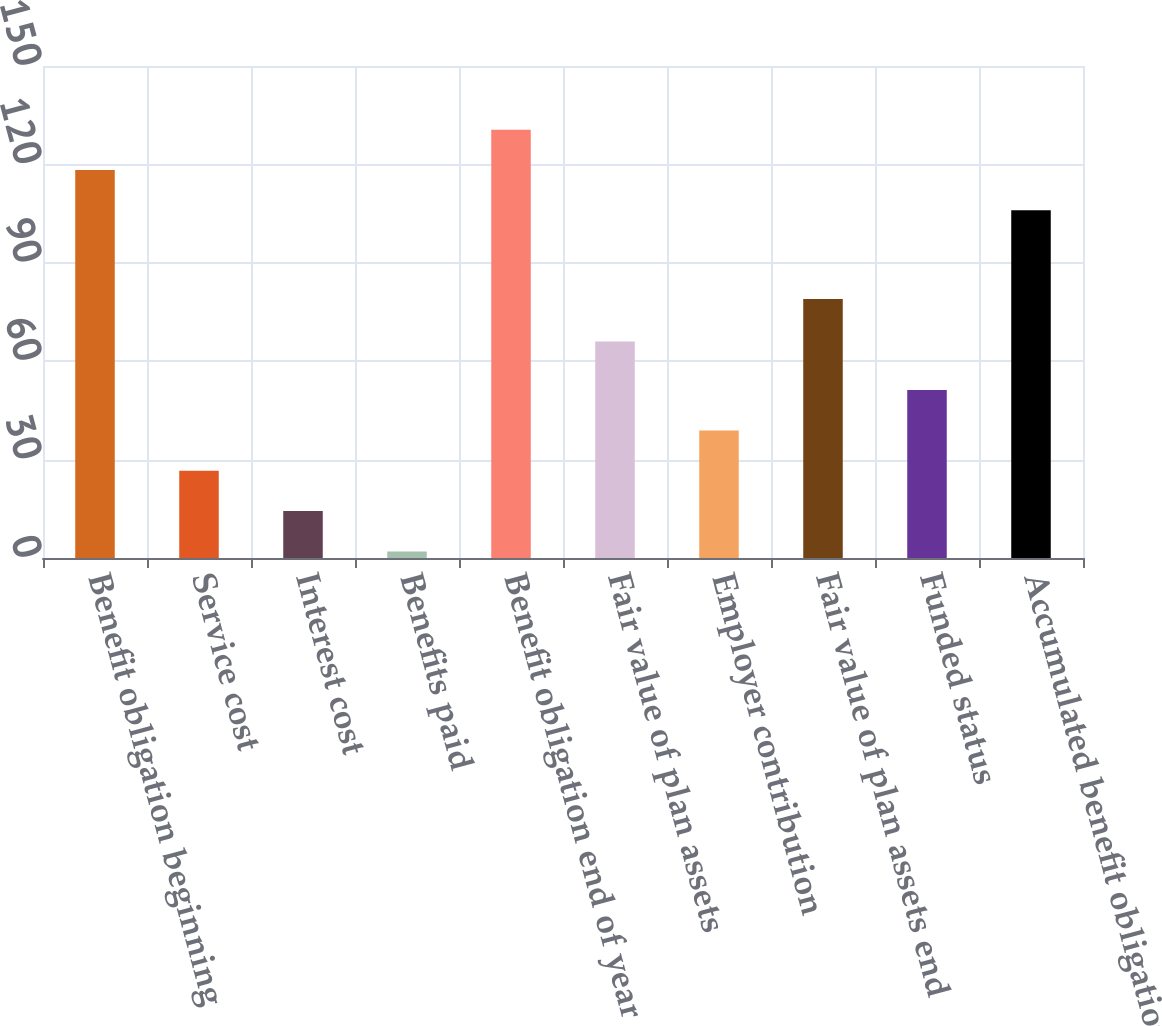<chart> <loc_0><loc_0><loc_500><loc_500><bar_chart><fcel>Benefit obligation beginning<fcel>Service cost<fcel>Interest cost<fcel>Benefits paid<fcel>Benefit obligation end of year<fcel>Fair value of plan assets<fcel>Employer contribution<fcel>Fair value of plan assets end<fcel>Funded status<fcel>Accumulated benefit obligation<nl><fcel>118.3<fcel>26.6<fcel>14.3<fcel>2<fcel>130.6<fcel>66<fcel>38.9<fcel>79<fcel>51.2<fcel>106<nl></chart> 